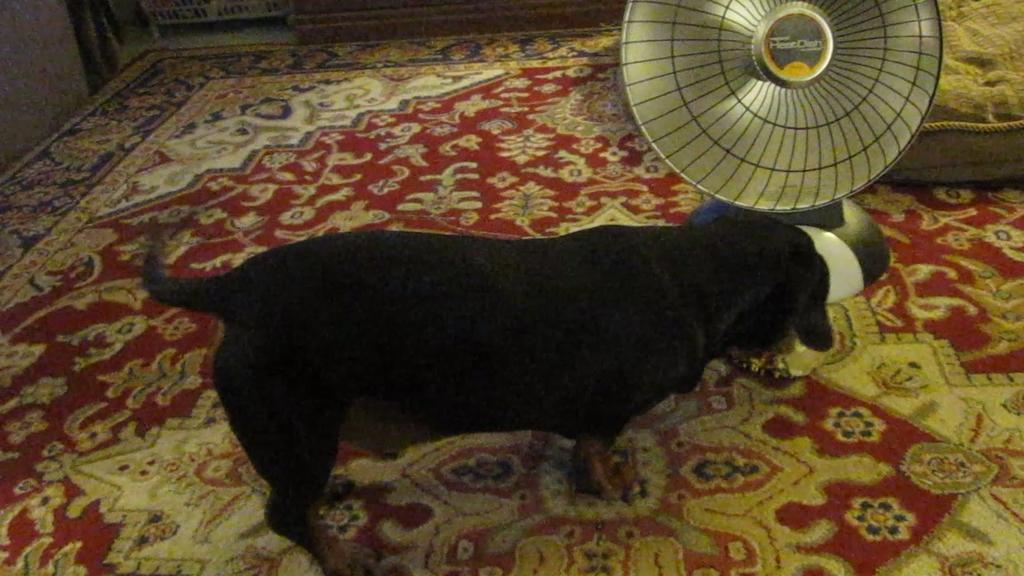What type of animal is in the image? There is a dog in the image. Where is the dog standing? The dog is standing on a carpet. What is the carpet placed on? The carpet is on the floor. What object is located beside the dog? There is a table fan beside the dog. What type of fuel is the dog using to power the table fan? The dog is not using any fuel to power the table fan, as the fan is likely powered by electricity. Additionally, the dog is not interacting with the fan in any way. 